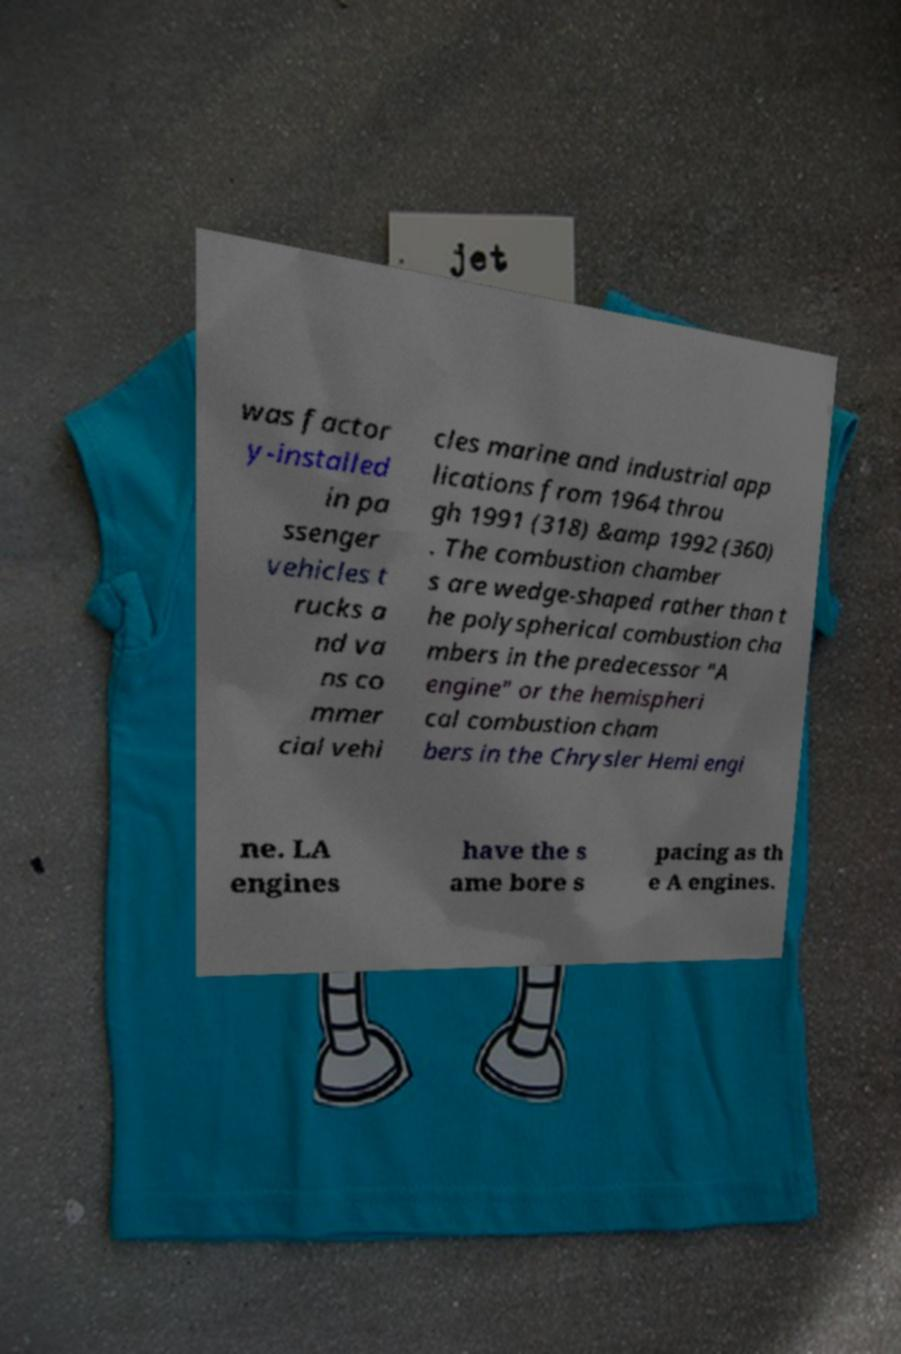Can you read and provide the text displayed in the image?This photo seems to have some interesting text. Can you extract and type it out for me? was factor y-installed in pa ssenger vehicles t rucks a nd va ns co mmer cial vehi cles marine and industrial app lications from 1964 throu gh 1991 (318) &amp 1992 (360) . The combustion chamber s are wedge-shaped rather than t he polyspherical combustion cha mbers in the predecessor "A engine" or the hemispheri cal combustion cham bers in the Chrysler Hemi engi ne. LA engines have the s ame bore s pacing as th e A engines. 